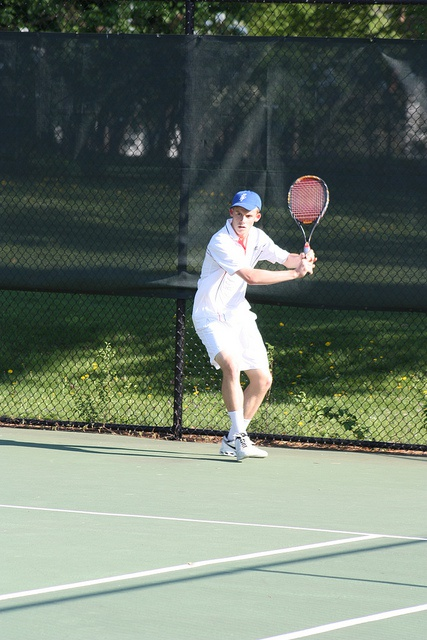Describe the objects in this image and their specific colors. I can see people in black, white, lavender, gray, and lightpink tones and tennis racket in black, lightpink, brown, darkgray, and gray tones in this image. 